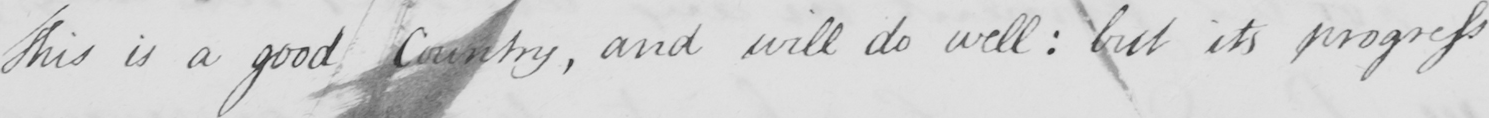What does this handwritten line say? This is a good Country, and will do well: but its progress 